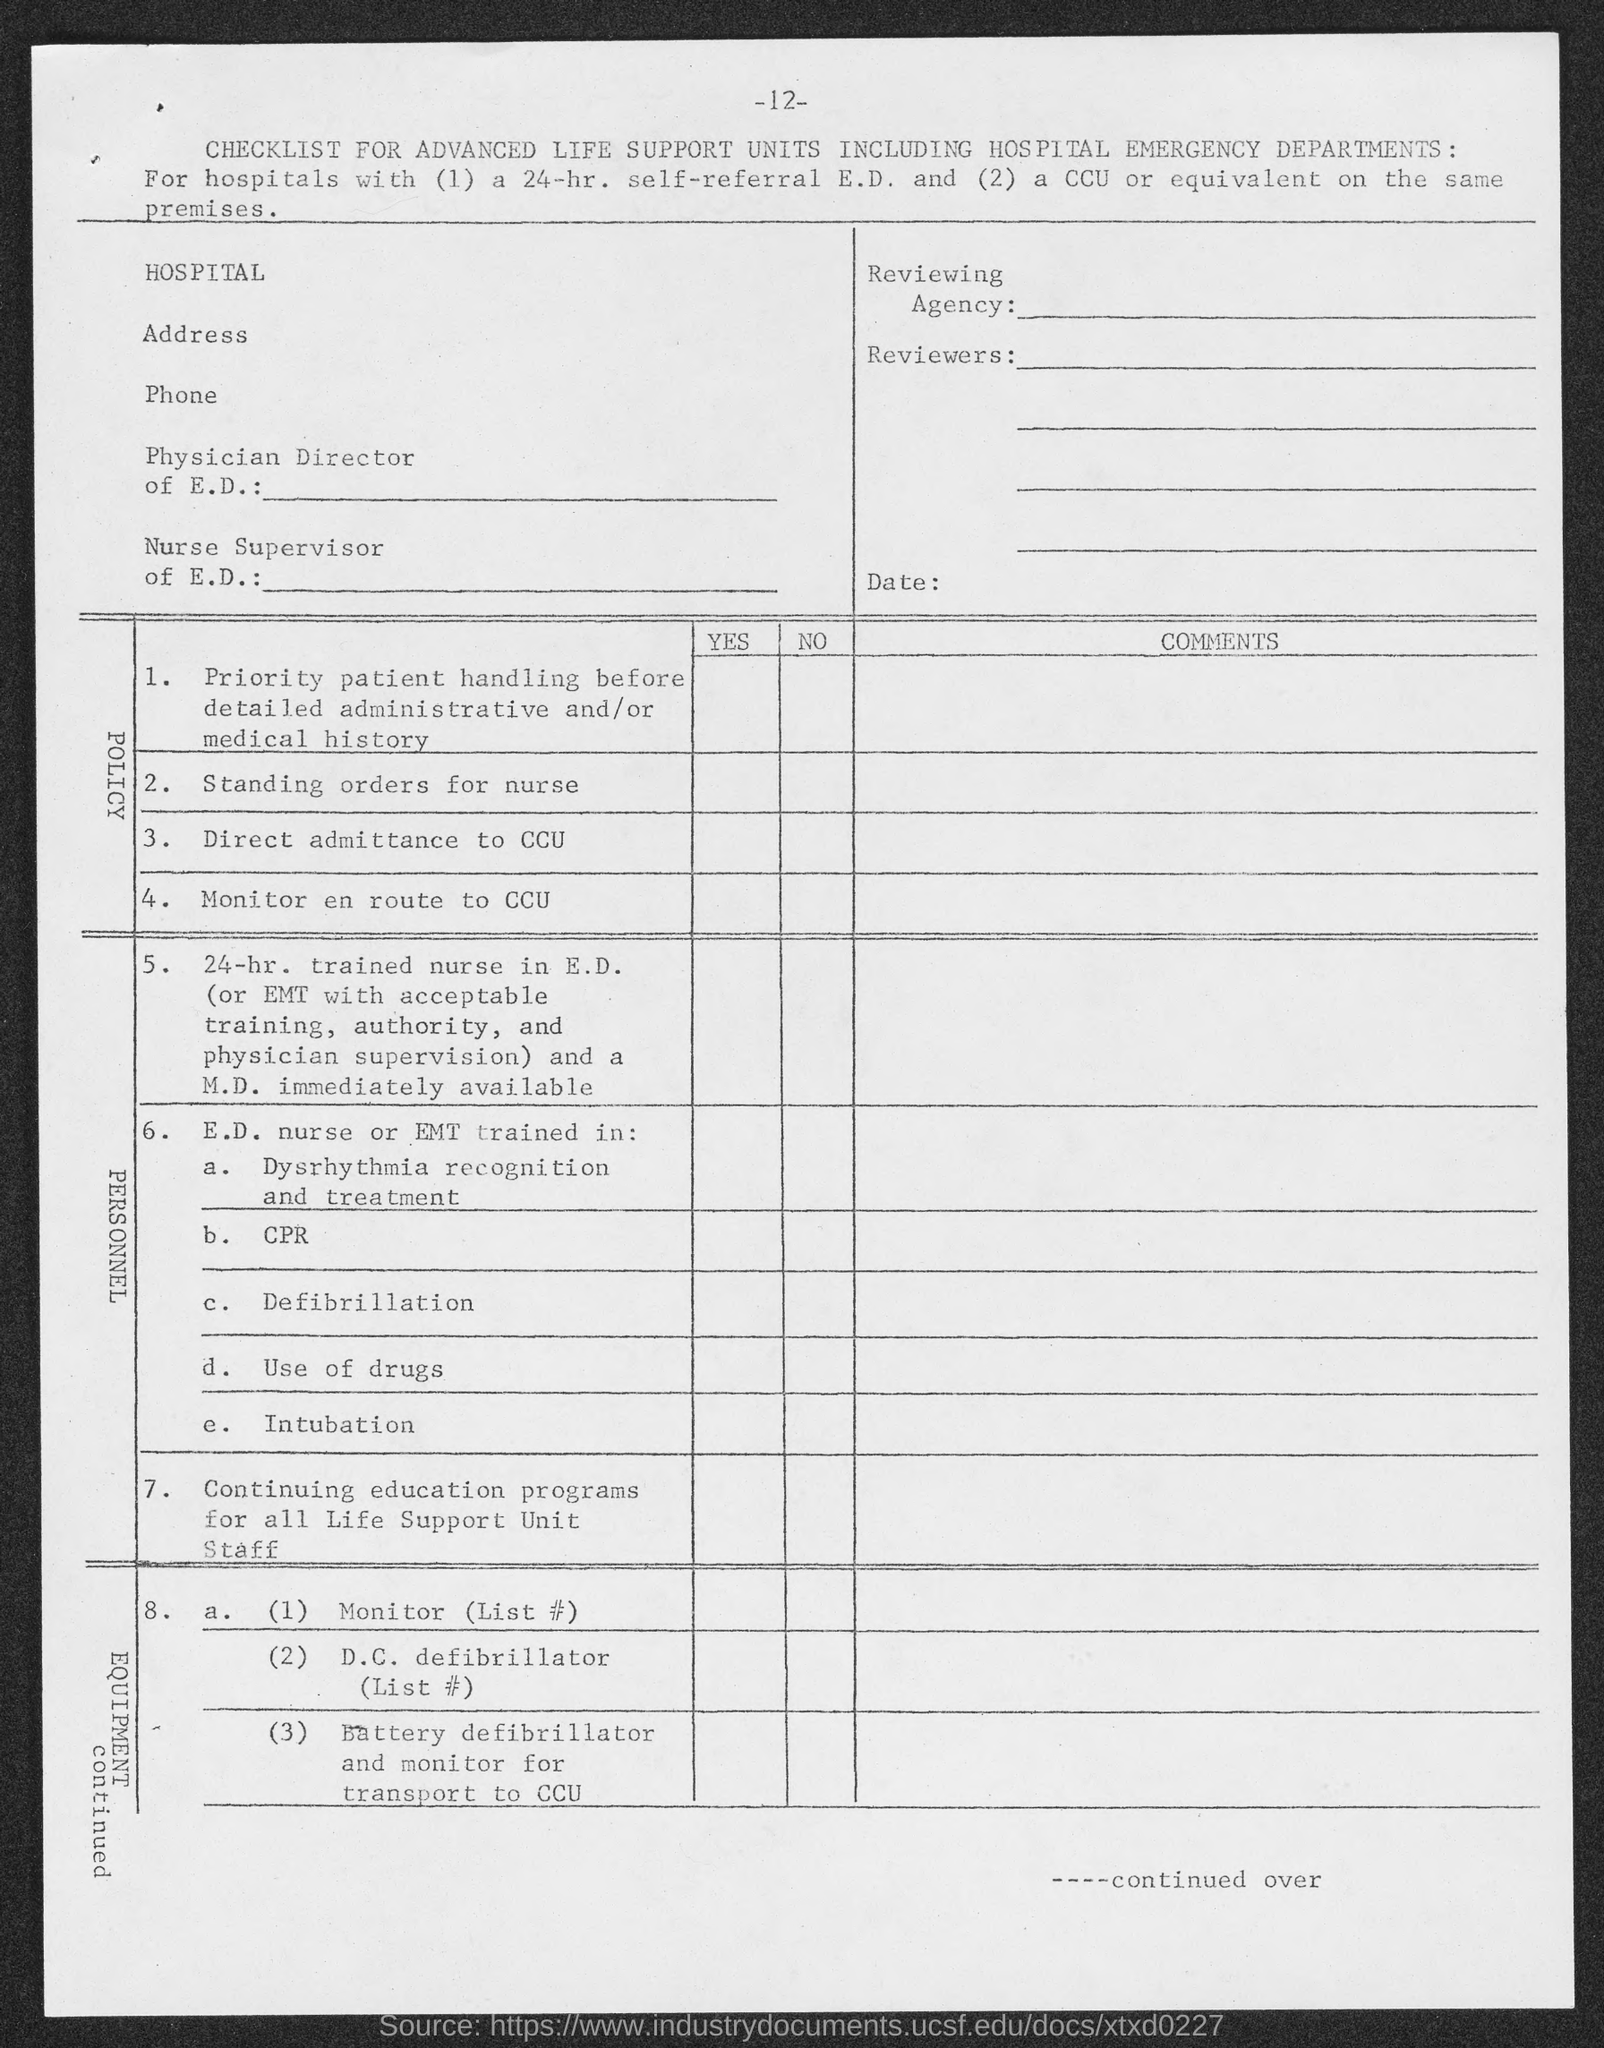Give some essential details in this illustration. The page number at the top of the page is -12-. 